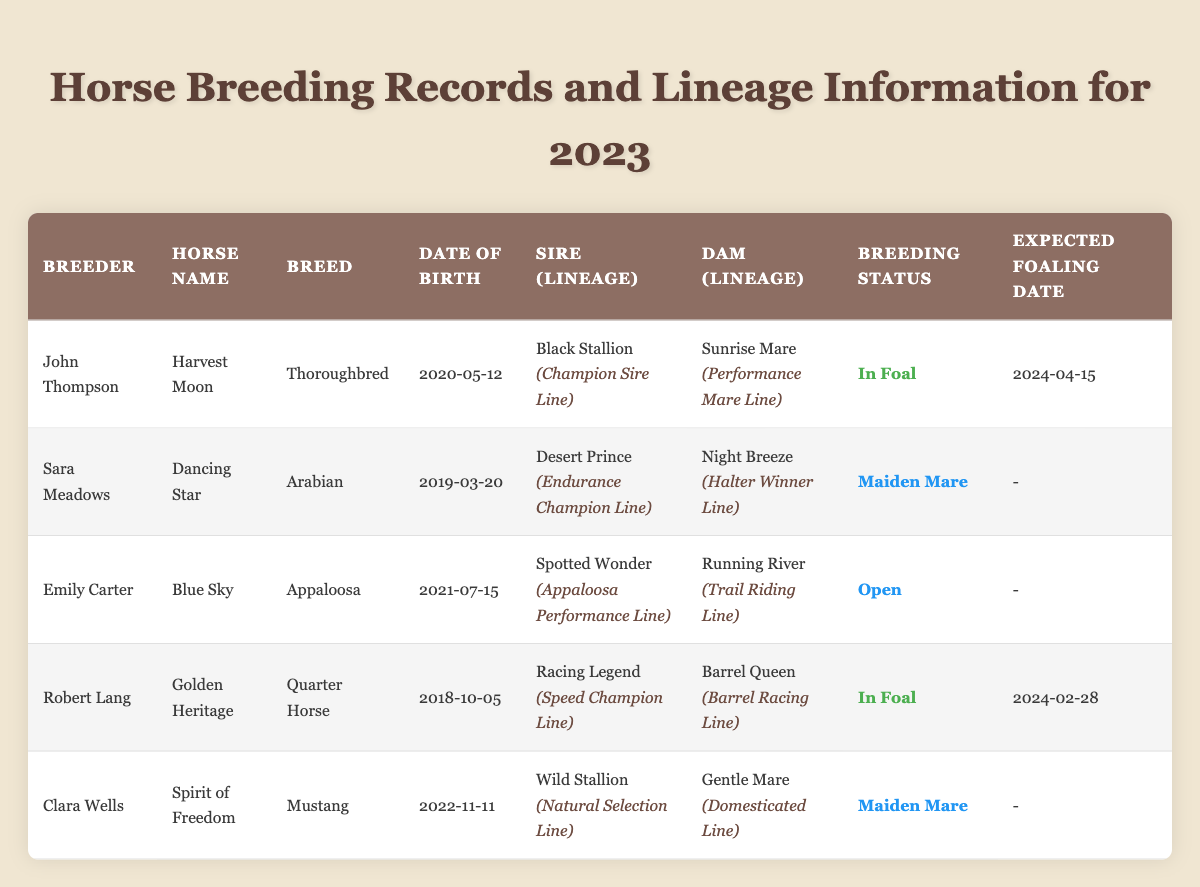What is the name of the horse that has a breeding status of "Open"? By reviewing the table, I can see that the breeding status "Open" is associated with the horse named "Blue Sky."
Answer: Blue Sky Who is the breeder of "Dancing Star"? The table shows that "Dancing Star" was bred by Sara Meadows.
Answer: Sara Meadows What is the expected foaling date for "Harvest Moon"? The expected foaling date for "Harvest Moon" is listed in the table as "2024-04-15."
Answer: 2024-04-15 Which horse was born on 2022-11-11? I check the Date of Birth column, and I find that "Spirit of Freedom" was born on 2022-11-11.
Answer: Spirit of Freedom How many horses have the breeding status "In Foal"? In the table, I find two horses: "Harvest Moon" and "Golden Heritage" have the breeding status of "In Foal." Therefore, the count is 2.
Answer: 2 What lineage does the sire of "Blue Sky" belong to? The table indicates that the sire of "Blue Sky" is "Spotted Wonder," and its lineage is "Appaloosa Performance Line."
Answer: Appaloosa Performance Line Is "Golden Heritage" a Quarter Horse? Looking at the breed of "Golden Heritage" in the table confirms that it is indeed a Quarter Horse.
Answer: Yes How many different breeds are represented in the table? By analyzing the breeds listed for each horse, I count four distinct breeds: Thoroughbred, Arabian, Appaloosa, and Quarter Horse. Therefore, the total number of different breeds is 4.
Answer: 4 What lineage does the dam of "Harvest Moon" belong to? The table reveals that the dam of "Harvest Moon" is "Sunrise Mare," and its lineage is "Performance Mare Line."
Answer: Performance Mare Line Which horse is expected to foal last in the table? By comparing the expected foaling dates: "Golden Heritage" is expected to foal on "2024-02-28," and "Harvest Moon" is on "2024-04-15." Thus, "Harvest Moon" has the latest expected foaling date.
Answer: Harvest Moon Are there any horses that do not have an expected foaling date? Reviewing the table shows that "Dancing Star," "Blue Sky," and "Spirit of Freedom" do not have an expected foaling date listed. Therefore, the answer is yes.
Answer: Yes 